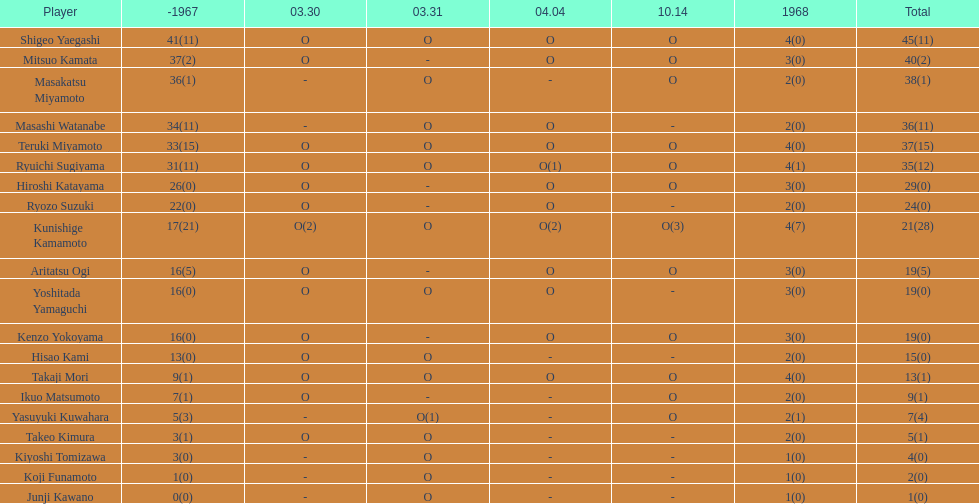Who accumulated more points, takaji mori or junji kawano? Takaji Mori. 